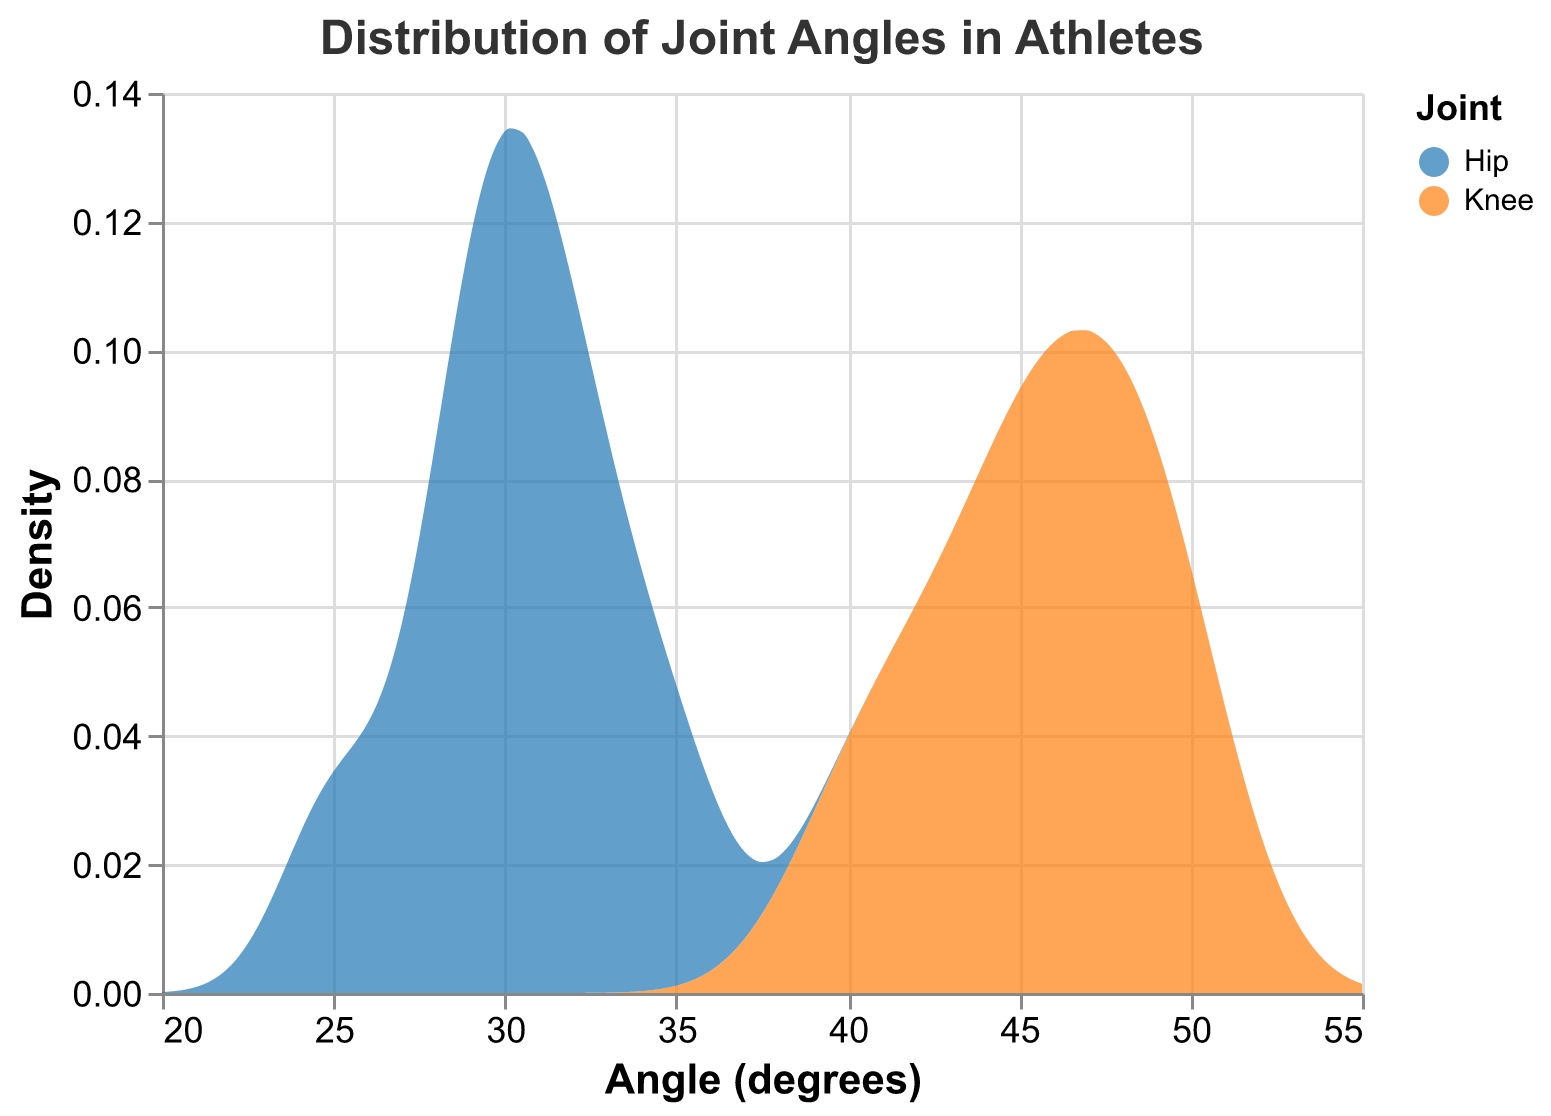What is the title of the figure? The title is typically found at the top of the figure and describes what the figure is about. Here, the title is "Distribution of Joint Angles in Athletes".
Answer: Distribution of Joint Angles in Athletes What is represented on the x-axis? The x-axis label indicates the variable plotted along this axis. In the given figure, the x-axis is labeled as "Angle (degrees)", indicating that it represents the joint angle measurements in degrees.
Answer: Angle (degrees) Which color represents the Knee joint? The color legend explains which colors correspond to each data group. In this case, the Knee joint is represented by the color "#1f77b4".
Answer: blue What is the range of angles shown on the x-axis in the figure? The x-axis range can be identified by looking at the minimum and maximum tick marks. The range of angles is from 20 degrees to 55 degrees, as indicated by the axis scale.
Answer: 20 to 55 degrees Which joint shows a higher density around 45 degrees? By observing the density lines at the 45-degree mark on the x-axis, we can see which joint has a higher y-value (density). The Knee joint shows a higher density around this angle because the density line is higher.
Answer: Knee What is the approximate density of the Hip joint at 30 degrees? Find 30 degrees on the x-axis and then look at the corresponding y-value (density) for the Hip joint. The density for the Hip joint at 30 degrees is around 0.15.
Answer: 0.15 Between which angle ranges do both joints have overlapping densities? Identify sections on the x-axis where density curves of both joints overlap. Both joints have overlapping densities approximately between angles 25 and 50 degrees.
Answer: 25 to 50 degrees Is there a distinct difference in density between the Knee and Hip joints at lower angles (e.g., around 25 degrees)? Examine the density values for both joints at around 25 degrees to determine whether there is a significant difference. At around 25 degrees, the Hip joint has a higher density compared to the Knee joint.
Answer: Yes Which joint appears to have a broader distribution range of angles? A broader distribution range will be indicated by a wider spread of the density curve along the x-axis. The Knee joint has a broader distribution range, extending from approximately 40 to 50 degrees, compared to the Hip joint.
Answer: Knee At approximately what angle does the Hip joint's density peak? Locate the highest point on the Hip joint's density curve, then find the corresponding x-axis value. The Hip joint's density peaks around 30 degrees.
Answer: 30 degrees 